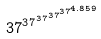Convert formula to latex. <formula><loc_0><loc_0><loc_500><loc_500>3 7 ^ { 3 7 ^ { 3 7 ^ { 3 7 ^ { 3 7 ^ { 4 . 8 5 9 } } } } }</formula> 